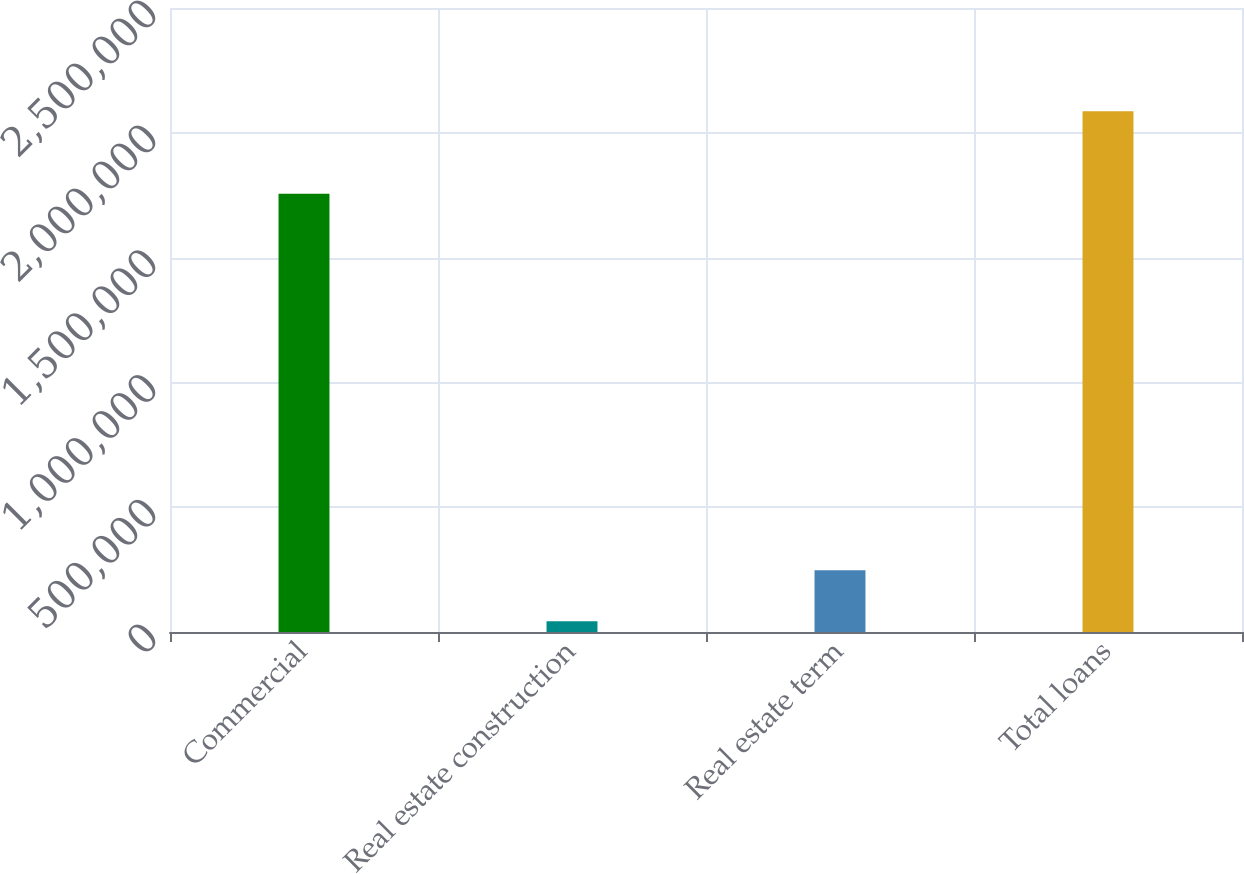<chart> <loc_0><loc_0><loc_500><loc_500><bar_chart><fcel>Commercial<fcel>Real estate construction<fcel>Real estate term<fcel>Total loans<nl><fcel>1.75618e+06<fcel>43178<fcel>247468<fcel>2.08608e+06<nl></chart> 